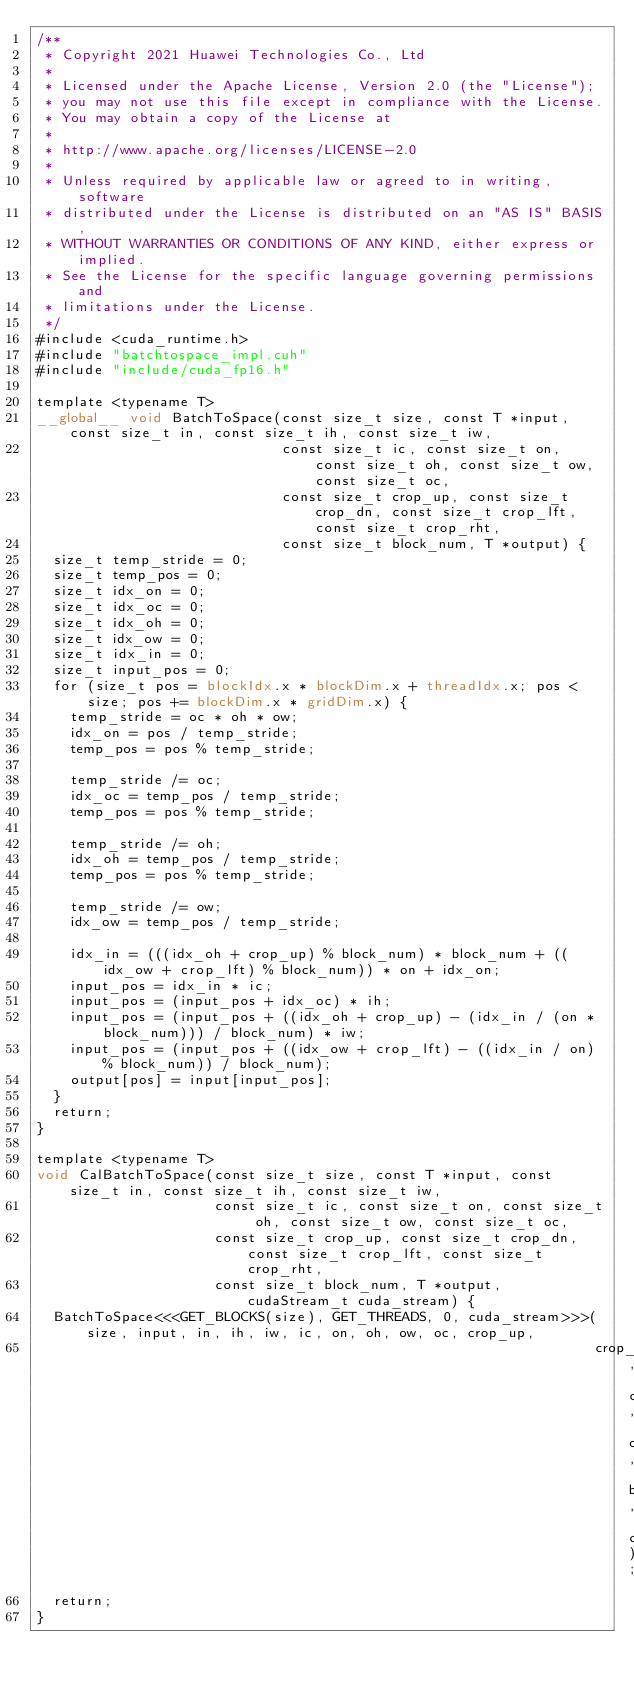<code> <loc_0><loc_0><loc_500><loc_500><_Cuda_>/**
 * Copyright 2021 Huawei Technologies Co., Ltd
 *
 * Licensed under the Apache License, Version 2.0 (the "License");
 * you may not use this file except in compliance with the License.
 * You may obtain a copy of the License at
 *
 * http://www.apache.org/licenses/LICENSE-2.0
 *
 * Unless required by applicable law or agreed to in writing, software
 * distributed under the License is distributed on an "AS IS" BASIS,
 * WITHOUT WARRANTIES OR CONDITIONS OF ANY KIND, either express or implied.
 * See the License for the specific language governing permissions and
 * limitations under the License.
 */
#include <cuda_runtime.h>
#include "batchtospace_impl.cuh"
#include "include/cuda_fp16.h"

template <typename T>
__global__ void BatchToSpace(const size_t size, const T *input, const size_t in, const size_t ih, const size_t iw,
                             const size_t ic, const size_t on, const size_t oh, const size_t ow, const size_t oc,
                             const size_t crop_up, const size_t crop_dn, const size_t crop_lft, const size_t crop_rht,
                             const size_t block_num, T *output) {
  size_t temp_stride = 0;
  size_t temp_pos = 0;
  size_t idx_on = 0;
  size_t idx_oc = 0;
  size_t idx_oh = 0;
  size_t idx_ow = 0;
  size_t idx_in = 0;
  size_t input_pos = 0;
  for (size_t pos = blockIdx.x * blockDim.x + threadIdx.x; pos < size; pos += blockDim.x * gridDim.x) {
    temp_stride = oc * oh * ow;
    idx_on = pos / temp_stride;
    temp_pos = pos % temp_stride;

    temp_stride /= oc;
    idx_oc = temp_pos / temp_stride;
    temp_pos = pos % temp_stride;

    temp_stride /= oh;
    idx_oh = temp_pos / temp_stride;
    temp_pos = pos % temp_stride;

    temp_stride /= ow;
    idx_ow = temp_pos / temp_stride;

    idx_in = (((idx_oh + crop_up) % block_num) * block_num + ((idx_ow + crop_lft) % block_num)) * on + idx_on;
    input_pos = idx_in * ic;
    input_pos = (input_pos + idx_oc) * ih;
    input_pos = (input_pos + ((idx_oh + crop_up) - (idx_in / (on * block_num))) / block_num) * iw;
    input_pos = (input_pos + ((idx_ow + crop_lft) - ((idx_in / on) % block_num)) / block_num);
    output[pos] = input[input_pos];
  }
  return;
}

template <typename T>
void CalBatchToSpace(const size_t size, const T *input, const size_t in, const size_t ih, const size_t iw,
                     const size_t ic, const size_t on, const size_t oh, const size_t ow, const size_t oc,
                     const size_t crop_up, const size_t crop_dn, const size_t crop_lft, const size_t crop_rht,
                     const size_t block_num, T *output, cudaStream_t cuda_stream) {
  BatchToSpace<<<GET_BLOCKS(size), GET_THREADS, 0, cuda_stream>>>(size, input, in, ih, iw, ic, on, oh, ow, oc, crop_up,
                                                                  crop_dn, crop_lft, crop_rht, block_num, output);
  return;
}
</code> 